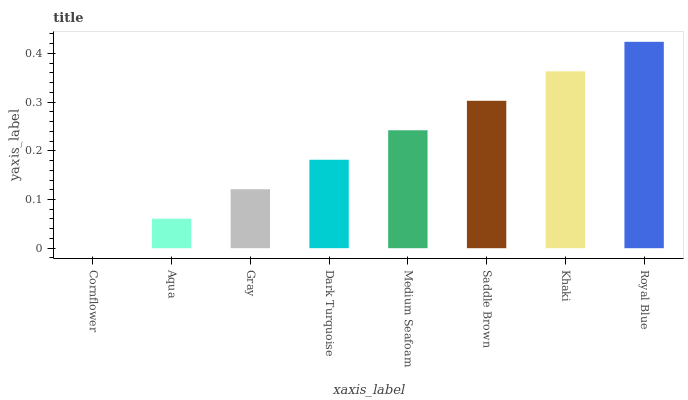Is Cornflower the minimum?
Answer yes or no. Yes. Is Royal Blue the maximum?
Answer yes or no. Yes. Is Aqua the minimum?
Answer yes or no. No. Is Aqua the maximum?
Answer yes or no. No. Is Aqua greater than Cornflower?
Answer yes or no. Yes. Is Cornflower less than Aqua?
Answer yes or no. Yes. Is Cornflower greater than Aqua?
Answer yes or no. No. Is Aqua less than Cornflower?
Answer yes or no. No. Is Medium Seafoam the high median?
Answer yes or no. Yes. Is Dark Turquoise the low median?
Answer yes or no. Yes. Is Royal Blue the high median?
Answer yes or no. No. Is Saddle Brown the low median?
Answer yes or no. No. 